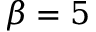Convert formula to latex. <formula><loc_0><loc_0><loc_500><loc_500>\beta = 5</formula> 